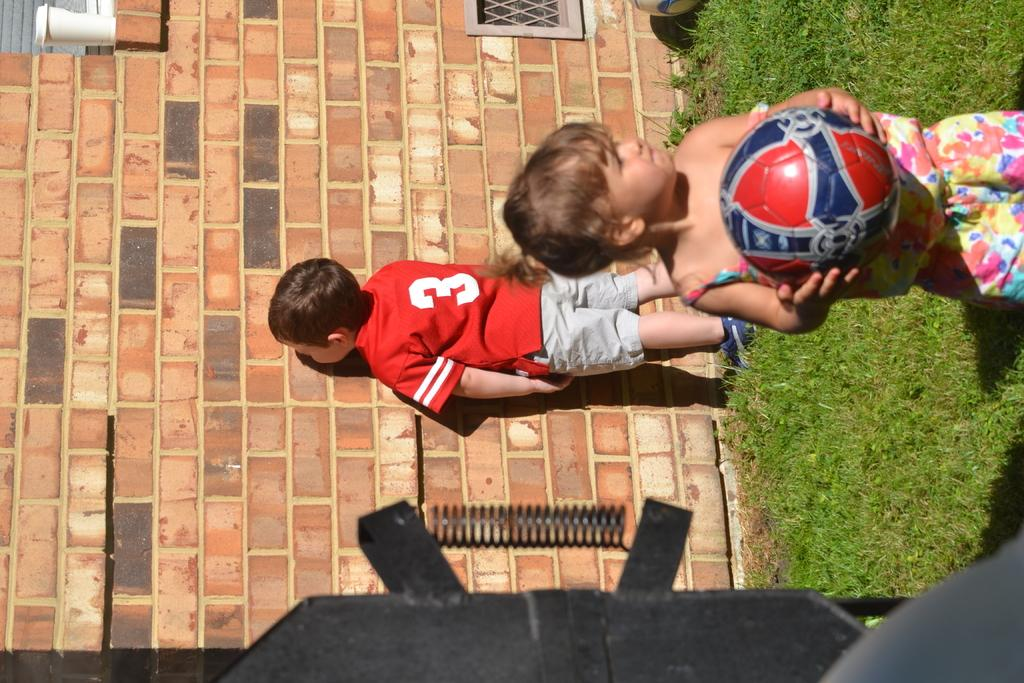What type of vegetation can be seen in the image? There is grass in the image. What object is present that might be used for playing? There is a ball in the image. How many people are in the image? There is a girl and a boy in the image. What object might be used for drinking? There is a glass in the image. What seasonal element can be seen in the image? There is a spring in the image. What other unspecified objects are present in the image? There are some unspecified objects in the image. What can be seen in the background of the image? There is a wall in the background of the image. What type of butter is being stored on the shelf in the image? There is no butter or shelf present in the image. How does the stomach of the girl in the image feel after eating the ice cream? There is no ice cream mentioned in the image, and the girl's stomach is not visible or discussed. 